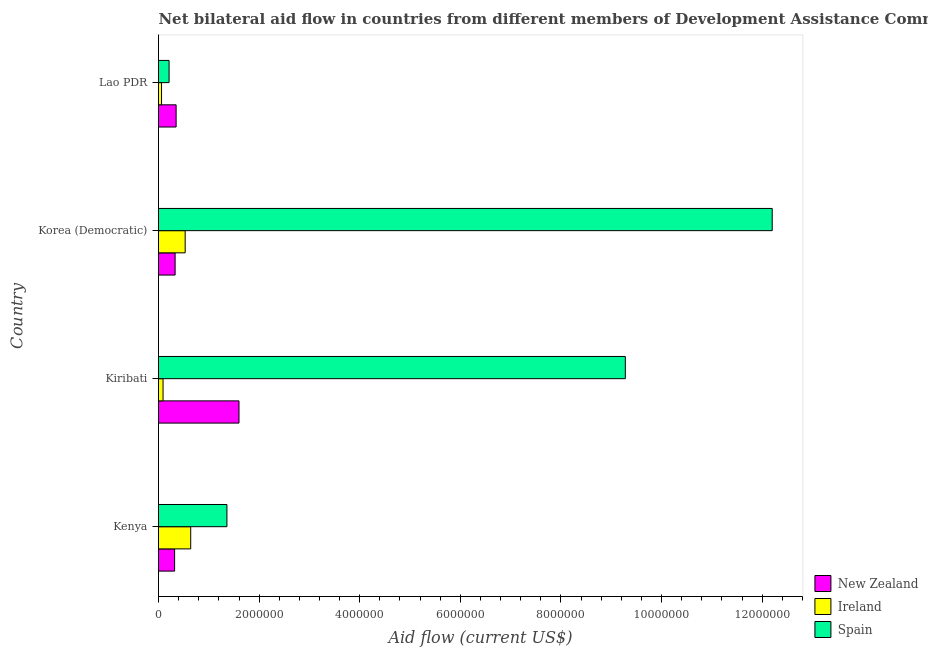How many groups of bars are there?
Keep it short and to the point. 4. Are the number of bars per tick equal to the number of legend labels?
Keep it short and to the point. Yes. Are the number of bars on each tick of the Y-axis equal?
Your answer should be compact. Yes. How many bars are there on the 1st tick from the top?
Give a very brief answer. 3. What is the label of the 1st group of bars from the top?
Ensure brevity in your answer.  Lao PDR. In how many cases, is the number of bars for a given country not equal to the number of legend labels?
Offer a very short reply. 0. What is the amount of aid provided by spain in Kenya?
Your response must be concise. 1.36e+06. Across all countries, what is the maximum amount of aid provided by ireland?
Give a very brief answer. 6.40e+05. Across all countries, what is the minimum amount of aid provided by spain?
Give a very brief answer. 2.10e+05. In which country was the amount of aid provided by new zealand maximum?
Ensure brevity in your answer.  Kiribati. In which country was the amount of aid provided by ireland minimum?
Ensure brevity in your answer.  Lao PDR. What is the total amount of aid provided by new zealand in the graph?
Your response must be concise. 2.60e+06. What is the difference between the amount of aid provided by ireland in Korea (Democratic) and that in Lao PDR?
Offer a terse response. 4.70e+05. What is the difference between the amount of aid provided by new zealand in Korea (Democratic) and the amount of aid provided by spain in Lao PDR?
Offer a terse response. 1.20e+05. What is the average amount of aid provided by new zealand per country?
Ensure brevity in your answer.  6.50e+05. What is the difference between the amount of aid provided by spain and amount of aid provided by new zealand in Lao PDR?
Offer a very short reply. -1.40e+05. In how many countries, is the amount of aid provided by spain greater than 400000 US$?
Your answer should be very brief. 3. What is the ratio of the amount of aid provided by spain in Kenya to that in Kiribati?
Keep it short and to the point. 0.15. Is the amount of aid provided by ireland in Korea (Democratic) less than that in Lao PDR?
Provide a succinct answer. No. What is the difference between the highest and the lowest amount of aid provided by new zealand?
Give a very brief answer. 1.28e+06. In how many countries, is the amount of aid provided by ireland greater than the average amount of aid provided by ireland taken over all countries?
Your answer should be compact. 2. Is the sum of the amount of aid provided by new zealand in Kenya and Lao PDR greater than the maximum amount of aid provided by spain across all countries?
Your answer should be compact. No. What does the 1st bar from the top in Kenya represents?
Provide a short and direct response. Spain. Is it the case that in every country, the sum of the amount of aid provided by new zealand and amount of aid provided by ireland is greater than the amount of aid provided by spain?
Provide a short and direct response. No. Are all the bars in the graph horizontal?
Ensure brevity in your answer.  Yes. Does the graph contain any zero values?
Your answer should be very brief. No. Does the graph contain grids?
Provide a short and direct response. No. Where does the legend appear in the graph?
Your response must be concise. Bottom right. How many legend labels are there?
Offer a very short reply. 3. What is the title of the graph?
Keep it short and to the point. Net bilateral aid flow in countries from different members of Development Assistance Committee. Does "Non-communicable diseases" appear as one of the legend labels in the graph?
Give a very brief answer. No. What is the label or title of the X-axis?
Your response must be concise. Aid flow (current US$). What is the Aid flow (current US$) of Ireland in Kenya?
Your answer should be very brief. 6.40e+05. What is the Aid flow (current US$) in Spain in Kenya?
Provide a succinct answer. 1.36e+06. What is the Aid flow (current US$) of New Zealand in Kiribati?
Your answer should be compact. 1.60e+06. What is the Aid flow (current US$) of Ireland in Kiribati?
Make the answer very short. 9.00e+04. What is the Aid flow (current US$) of Spain in Kiribati?
Ensure brevity in your answer.  9.28e+06. What is the Aid flow (current US$) in Ireland in Korea (Democratic)?
Offer a terse response. 5.30e+05. What is the Aid flow (current US$) in Spain in Korea (Democratic)?
Provide a succinct answer. 1.22e+07. What is the Aid flow (current US$) in Ireland in Lao PDR?
Keep it short and to the point. 6.00e+04. What is the Aid flow (current US$) in Spain in Lao PDR?
Your answer should be compact. 2.10e+05. Across all countries, what is the maximum Aid flow (current US$) in New Zealand?
Your answer should be very brief. 1.60e+06. Across all countries, what is the maximum Aid flow (current US$) in Ireland?
Make the answer very short. 6.40e+05. Across all countries, what is the maximum Aid flow (current US$) in Spain?
Provide a short and direct response. 1.22e+07. Across all countries, what is the minimum Aid flow (current US$) of New Zealand?
Offer a terse response. 3.20e+05. Across all countries, what is the minimum Aid flow (current US$) in Spain?
Provide a short and direct response. 2.10e+05. What is the total Aid flow (current US$) in New Zealand in the graph?
Your answer should be very brief. 2.60e+06. What is the total Aid flow (current US$) in Ireland in the graph?
Offer a terse response. 1.32e+06. What is the total Aid flow (current US$) in Spain in the graph?
Make the answer very short. 2.30e+07. What is the difference between the Aid flow (current US$) in New Zealand in Kenya and that in Kiribati?
Provide a short and direct response. -1.28e+06. What is the difference between the Aid flow (current US$) in Spain in Kenya and that in Kiribati?
Offer a terse response. -7.92e+06. What is the difference between the Aid flow (current US$) of New Zealand in Kenya and that in Korea (Democratic)?
Make the answer very short. -10000. What is the difference between the Aid flow (current US$) in Ireland in Kenya and that in Korea (Democratic)?
Provide a short and direct response. 1.10e+05. What is the difference between the Aid flow (current US$) in Spain in Kenya and that in Korea (Democratic)?
Offer a terse response. -1.08e+07. What is the difference between the Aid flow (current US$) in New Zealand in Kenya and that in Lao PDR?
Your answer should be very brief. -3.00e+04. What is the difference between the Aid flow (current US$) in Ireland in Kenya and that in Lao PDR?
Give a very brief answer. 5.80e+05. What is the difference between the Aid flow (current US$) of Spain in Kenya and that in Lao PDR?
Offer a very short reply. 1.15e+06. What is the difference between the Aid flow (current US$) in New Zealand in Kiribati and that in Korea (Democratic)?
Ensure brevity in your answer.  1.27e+06. What is the difference between the Aid flow (current US$) in Ireland in Kiribati and that in Korea (Democratic)?
Offer a very short reply. -4.40e+05. What is the difference between the Aid flow (current US$) in Spain in Kiribati and that in Korea (Democratic)?
Offer a terse response. -2.92e+06. What is the difference between the Aid flow (current US$) of New Zealand in Kiribati and that in Lao PDR?
Your answer should be very brief. 1.25e+06. What is the difference between the Aid flow (current US$) of Ireland in Kiribati and that in Lao PDR?
Make the answer very short. 3.00e+04. What is the difference between the Aid flow (current US$) of Spain in Kiribati and that in Lao PDR?
Provide a succinct answer. 9.07e+06. What is the difference between the Aid flow (current US$) in New Zealand in Korea (Democratic) and that in Lao PDR?
Give a very brief answer. -2.00e+04. What is the difference between the Aid flow (current US$) of Ireland in Korea (Democratic) and that in Lao PDR?
Give a very brief answer. 4.70e+05. What is the difference between the Aid flow (current US$) of Spain in Korea (Democratic) and that in Lao PDR?
Your answer should be very brief. 1.20e+07. What is the difference between the Aid flow (current US$) of New Zealand in Kenya and the Aid flow (current US$) of Ireland in Kiribati?
Your answer should be very brief. 2.30e+05. What is the difference between the Aid flow (current US$) of New Zealand in Kenya and the Aid flow (current US$) of Spain in Kiribati?
Offer a terse response. -8.96e+06. What is the difference between the Aid flow (current US$) in Ireland in Kenya and the Aid flow (current US$) in Spain in Kiribati?
Your answer should be compact. -8.64e+06. What is the difference between the Aid flow (current US$) in New Zealand in Kenya and the Aid flow (current US$) in Spain in Korea (Democratic)?
Keep it short and to the point. -1.19e+07. What is the difference between the Aid flow (current US$) of Ireland in Kenya and the Aid flow (current US$) of Spain in Korea (Democratic)?
Give a very brief answer. -1.16e+07. What is the difference between the Aid flow (current US$) in New Zealand in Kenya and the Aid flow (current US$) in Spain in Lao PDR?
Offer a very short reply. 1.10e+05. What is the difference between the Aid flow (current US$) in Ireland in Kenya and the Aid flow (current US$) in Spain in Lao PDR?
Your answer should be very brief. 4.30e+05. What is the difference between the Aid flow (current US$) in New Zealand in Kiribati and the Aid flow (current US$) in Ireland in Korea (Democratic)?
Offer a very short reply. 1.07e+06. What is the difference between the Aid flow (current US$) of New Zealand in Kiribati and the Aid flow (current US$) of Spain in Korea (Democratic)?
Your answer should be compact. -1.06e+07. What is the difference between the Aid flow (current US$) of Ireland in Kiribati and the Aid flow (current US$) of Spain in Korea (Democratic)?
Provide a succinct answer. -1.21e+07. What is the difference between the Aid flow (current US$) in New Zealand in Kiribati and the Aid flow (current US$) in Ireland in Lao PDR?
Your answer should be very brief. 1.54e+06. What is the difference between the Aid flow (current US$) of New Zealand in Kiribati and the Aid flow (current US$) of Spain in Lao PDR?
Provide a short and direct response. 1.39e+06. What is the difference between the Aid flow (current US$) of Ireland in Kiribati and the Aid flow (current US$) of Spain in Lao PDR?
Provide a succinct answer. -1.20e+05. What is the difference between the Aid flow (current US$) in New Zealand in Korea (Democratic) and the Aid flow (current US$) in Ireland in Lao PDR?
Your answer should be compact. 2.70e+05. What is the difference between the Aid flow (current US$) of Ireland in Korea (Democratic) and the Aid flow (current US$) of Spain in Lao PDR?
Keep it short and to the point. 3.20e+05. What is the average Aid flow (current US$) of New Zealand per country?
Make the answer very short. 6.50e+05. What is the average Aid flow (current US$) of Ireland per country?
Keep it short and to the point. 3.30e+05. What is the average Aid flow (current US$) of Spain per country?
Provide a succinct answer. 5.76e+06. What is the difference between the Aid flow (current US$) of New Zealand and Aid flow (current US$) of Ireland in Kenya?
Make the answer very short. -3.20e+05. What is the difference between the Aid flow (current US$) in New Zealand and Aid flow (current US$) in Spain in Kenya?
Ensure brevity in your answer.  -1.04e+06. What is the difference between the Aid flow (current US$) in Ireland and Aid flow (current US$) in Spain in Kenya?
Provide a succinct answer. -7.20e+05. What is the difference between the Aid flow (current US$) of New Zealand and Aid flow (current US$) of Ireland in Kiribati?
Provide a short and direct response. 1.51e+06. What is the difference between the Aid flow (current US$) of New Zealand and Aid flow (current US$) of Spain in Kiribati?
Your answer should be compact. -7.68e+06. What is the difference between the Aid flow (current US$) in Ireland and Aid flow (current US$) in Spain in Kiribati?
Your answer should be compact. -9.19e+06. What is the difference between the Aid flow (current US$) of New Zealand and Aid flow (current US$) of Ireland in Korea (Democratic)?
Make the answer very short. -2.00e+05. What is the difference between the Aid flow (current US$) of New Zealand and Aid flow (current US$) of Spain in Korea (Democratic)?
Make the answer very short. -1.19e+07. What is the difference between the Aid flow (current US$) of Ireland and Aid flow (current US$) of Spain in Korea (Democratic)?
Offer a very short reply. -1.17e+07. What is the difference between the Aid flow (current US$) in New Zealand and Aid flow (current US$) in Ireland in Lao PDR?
Your answer should be very brief. 2.90e+05. What is the difference between the Aid flow (current US$) of New Zealand and Aid flow (current US$) of Spain in Lao PDR?
Your answer should be very brief. 1.40e+05. What is the ratio of the Aid flow (current US$) of Ireland in Kenya to that in Kiribati?
Give a very brief answer. 7.11. What is the ratio of the Aid flow (current US$) in Spain in Kenya to that in Kiribati?
Offer a very short reply. 0.15. What is the ratio of the Aid flow (current US$) in New Zealand in Kenya to that in Korea (Democratic)?
Your answer should be very brief. 0.97. What is the ratio of the Aid flow (current US$) of Ireland in Kenya to that in Korea (Democratic)?
Make the answer very short. 1.21. What is the ratio of the Aid flow (current US$) in Spain in Kenya to that in Korea (Democratic)?
Offer a terse response. 0.11. What is the ratio of the Aid flow (current US$) in New Zealand in Kenya to that in Lao PDR?
Provide a succinct answer. 0.91. What is the ratio of the Aid flow (current US$) of Ireland in Kenya to that in Lao PDR?
Keep it short and to the point. 10.67. What is the ratio of the Aid flow (current US$) of Spain in Kenya to that in Lao PDR?
Offer a very short reply. 6.48. What is the ratio of the Aid flow (current US$) of New Zealand in Kiribati to that in Korea (Democratic)?
Give a very brief answer. 4.85. What is the ratio of the Aid flow (current US$) in Ireland in Kiribati to that in Korea (Democratic)?
Ensure brevity in your answer.  0.17. What is the ratio of the Aid flow (current US$) in Spain in Kiribati to that in Korea (Democratic)?
Give a very brief answer. 0.76. What is the ratio of the Aid flow (current US$) in New Zealand in Kiribati to that in Lao PDR?
Provide a succinct answer. 4.57. What is the ratio of the Aid flow (current US$) in Spain in Kiribati to that in Lao PDR?
Make the answer very short. 44.19. What is the ratio of the Aid flow (current US$) of New Zealand in Korea (Democratic) to that in Lao PDR?
Keep it short and to the point. 0.94. What is the ratio of the Aid flow (current US$) in Ireland in Korea (Democratic) to that in Lao PDR?
Give a very brief answer. 8.83. What is the ratio of the Aid flow (current US$) of Spain in Korea (Democratic) to that in Lao PDR?
Provide a short and direct response. 58.1. What is the difference between the highest and the second highest Aid flow (current US$) in New Zealand?
Your answer should be compact. 1.25e+06. What is the difference between the highest and the second highest Aid flow (current US$) in Spain?
Your response must be concise. 2.92e+06. What is the difference between the highest and the lowest Aid flow (current US$) of New Zealand?
Offer a terse response. 1.28e+06. What is the difference between the highest and the lowest Aid flow (current US$) of Ireland?
Ensure brevity in your answer.  5.80e+05. What is the difference between the highest and the lowest Aid flow (current US$) in Spain?
Make the answer very short. 1.20e+07. 